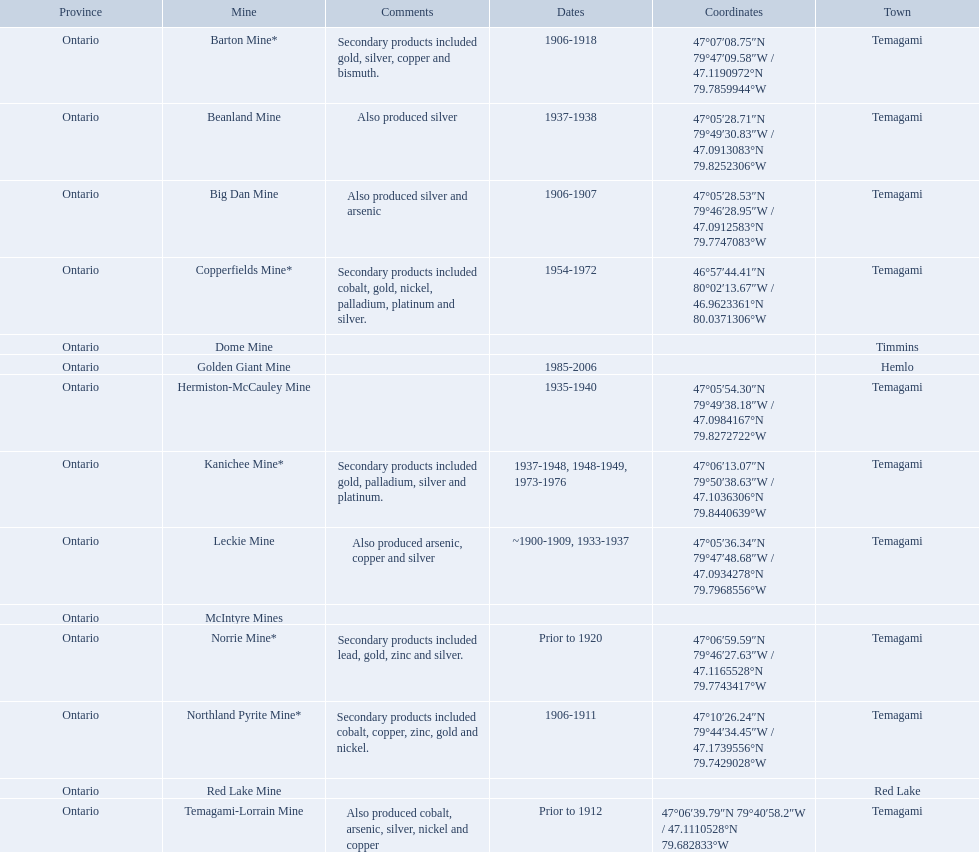What years was the golden giant mine open for? 1985-2006. What years was the beanland mine open? 1937-1938. Which of these two mines was open longer? Golden Giant Mine. 